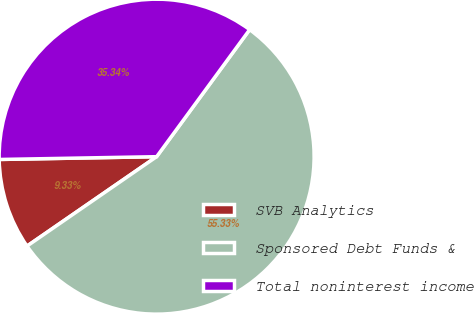<chart> <loc_0><loc_0><loc_500><loc_500><pie_chart><fcel>SVB Analytics<fcel>Sponsored Debt Funds &<fcel>Total noninterest income<nl><fcel>9.33%<fcel>55.33%<fcel>35.34%<nl></chart> 